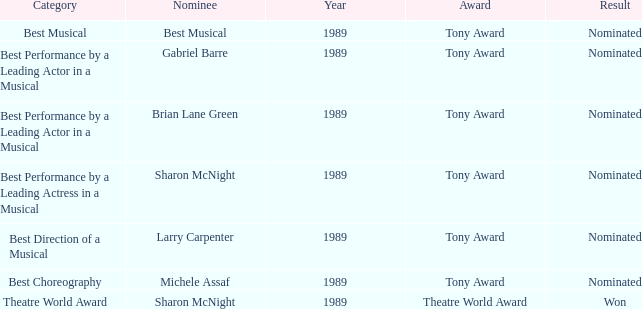What was the nominee of best musical Best Musical. 